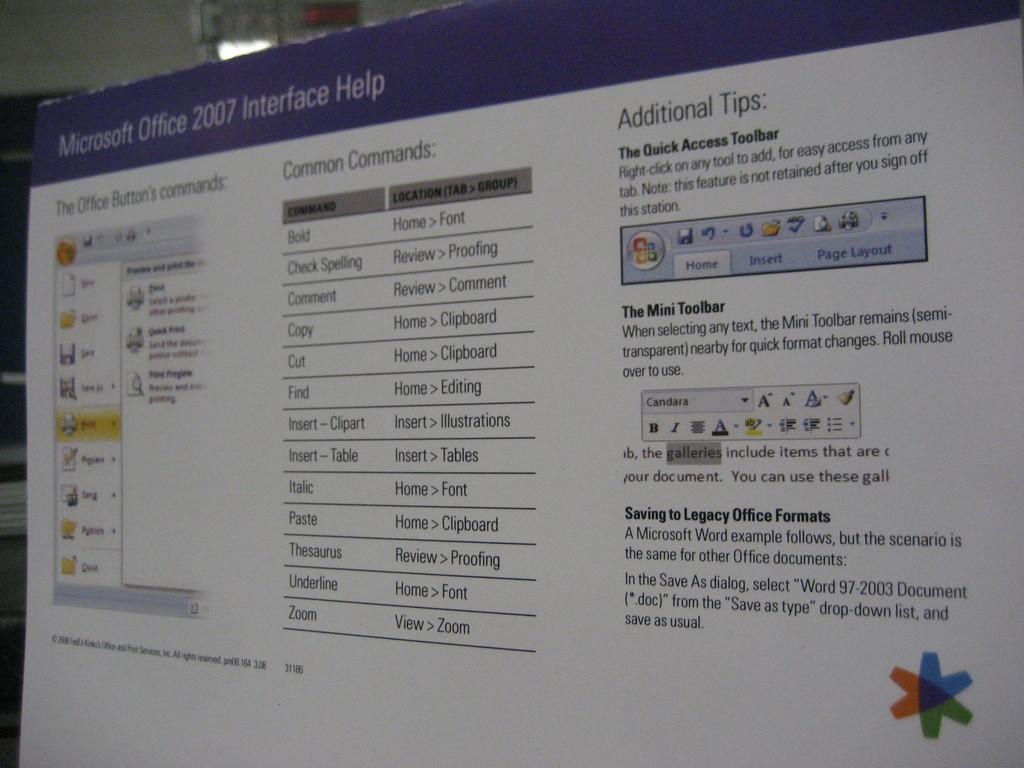What is the title of the page in the computer?
Ensure brevity in your answer.  Microsoft office 2007 interface help. 